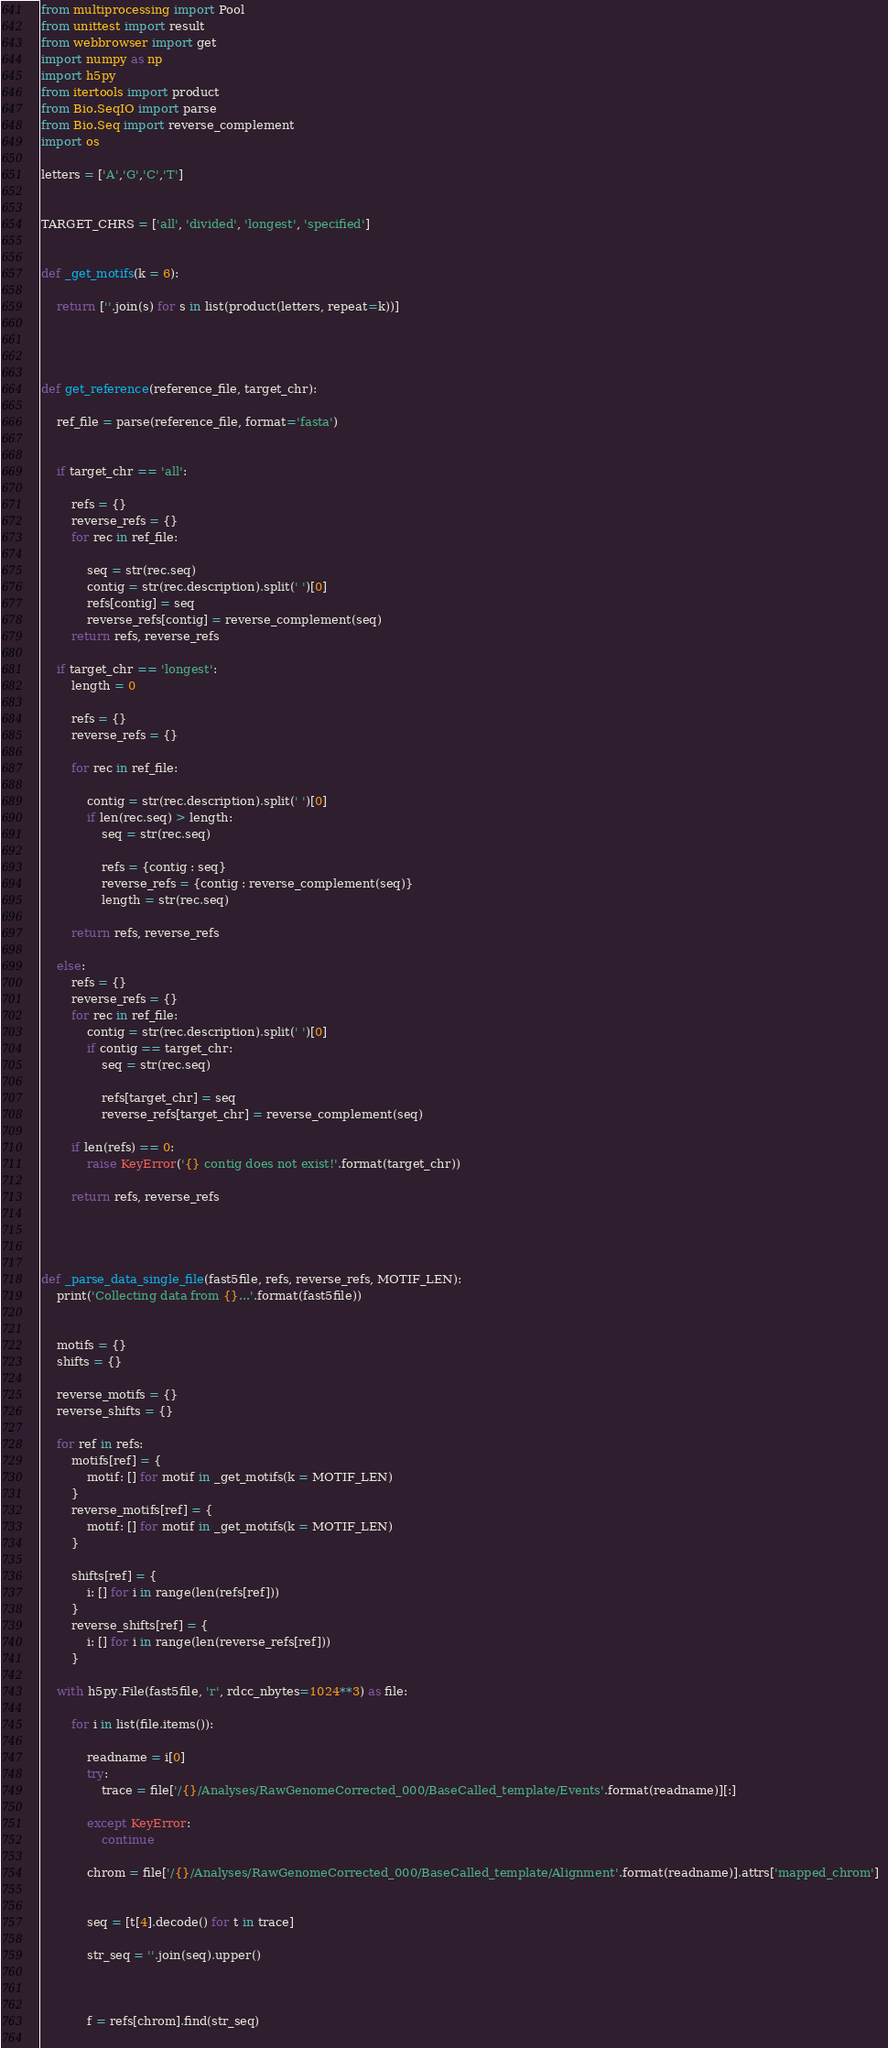Convert code to text. <code><loc_0><loc_0><loc_500><loc_500><_Python_>from multiprocessing import Pool
from unittest import result
from webbrowser import get
import numpy as np
import h5py
from itertools import product
from Bio.SeqIO import parse
from Bio.Seq import reverse_complement
import os

letters = ['A','G','C','T']


TARGET_CHRS = ['all', 'divided', 'longest', 'specified']


def _get_motifs(k = 6):

    return [''.join(s) for s in list(product(letters, repeat=k))]




def get_reference(reference_file, target_chr):

    ref_file = parse(reference_file, format='fasta')

    
    if target_chr == 'all':

        refs = {}
        reverse_refs = {}        
        for rec in ref_file:
            
            seq = str(rec.seq)
            contig = str(rec.description).split(' ')[0]
            refs[contig] = seq
            reverse_refs[contig] = reverse_complement(seq)
        return refs, reverse_refs
    
    if target_chr == 'longest':
        length = 0

        refs = {}
        reverse_refs = {}

        for rec in ref_file:
            
            contig = str(rec.description).split(' ')[0]
            if len(rec.seq) > length:
                seq = str(rec.seq)
                
                refs = {contig : seq}
                reverse_refs = {contig : reverse_complement(seq)}
                length = str(rec.seq)

        return refs, reverse_refs

    else:
        refs = {}
        reverse_refs = {}
        for rec in ref_file:
            contig = str(rec.description).split(' ')[0]
            if contig == target_chr:
                seq = str(rec.seq)

                refs[target_chr] = seq
                reverse_refs[target_chr] = reverse_complement(seq)
        
        if len(refs) == 0:
            raise KeyError('{} contig does not exist!'.format(target_chr))

        return refs, reverse_refs

    


def _parse_data_single_file(fast5file, refs, reverse_refs, MOTIF_LEN):
    print('Collecting data from {}...'.format(fast5file))

    
    motifs = {}
    shifts = {}

    reverse_motifs = {}
    reverse_shifts = {}

    for ref in refs:
        motifs[ref] = {
            motif: [] for motif in _get_motifs(k = MOTIF_LEN)
        }
        reverse_motifs[ref] = {
            motif: [] for motif in _get_motifs(k = MOTIF_LEN)
        }

        shifts[ref] = {
            i: [] for i in range(len(refs[ref]))
        }
        reverse_shifts[ref] = {
            i: [] for i in range(len(reverse_refs[ref]))
        }

    with h5py.File(fast5file, 'r', rdcc_nbytes=1024**3) as file:

        for i in list(file.items()):
            
            readname = i[0]
            try:
                trace = file['/{}/Analyses/RawGenomeCorrected_000/BaseCalled_template/Events'.format(readname)][:]

            except KeyError:
                continue
                
            chrom = file['/{}/Analyses/RawGenomeCorrected_000/BaseCalled_template/Alignment'.format(readname)].attrs['mapped_chrom']  
                
                
            seq = [t[4].decode() for t in trace]

            str_seq = ''.join(seq).upper()

            
        
            f = refs[chrom].find(str_seq)
            </code> 